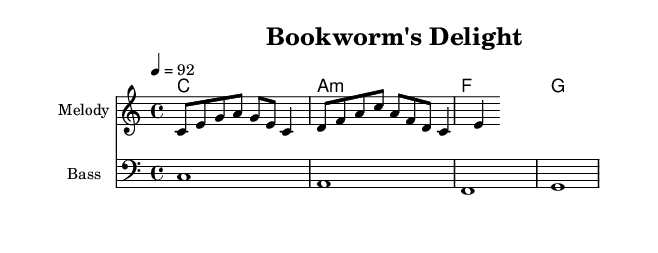What is the key signature of this music? The key signature indicated is C major, which is noted in the global section of the code. C major has no sharps or flats.
Answer: C major What is the time signature of this piece? The time signature is specified in the global section as 4/4, which means there are four beats per measure and the quarter note gets one beat.
Answer: 4/4 What is the tempo marking for this music? The tempo marking states "4 = 92", indicating that there are 92 beats per minute for the quarter note. This is also mentioned in the global section.
Answer: 92 How many measures are in the melody section? By analyzing the notes listed in the melody, it contains a sequence of eight eighth notes and four quarter notes, which can be grouped into four measures when counting them according to the 4/4 time signature.
Answer: 4 Who are some of the authors mentioned in the lyrics? The lyrics explicitly name Shakespeare, Austen, Dickens, and Poe as classic literature authors, which is evident in the text section of the code.
Answer: Shakespeare, Austen, Dickens, Poe What type of music is this arrangement? The arrangement is structured as a rap, which can be inferred from the educational lyrics about classic authors and the rhythmical and spoken style characteristic of rap music.
Answer: Rap What is the harmonic progression used in this piece? The harmonic progression observed in the chord mode section shows a sequential using C major, A minor, F major, and G major chords, characteristic of stable chord progressions.
Answer: C A minor F G 